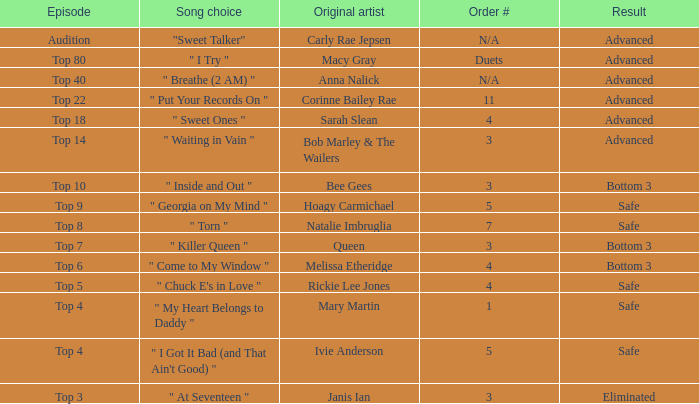What was the result of the Top 3 episode? Eliminated. 